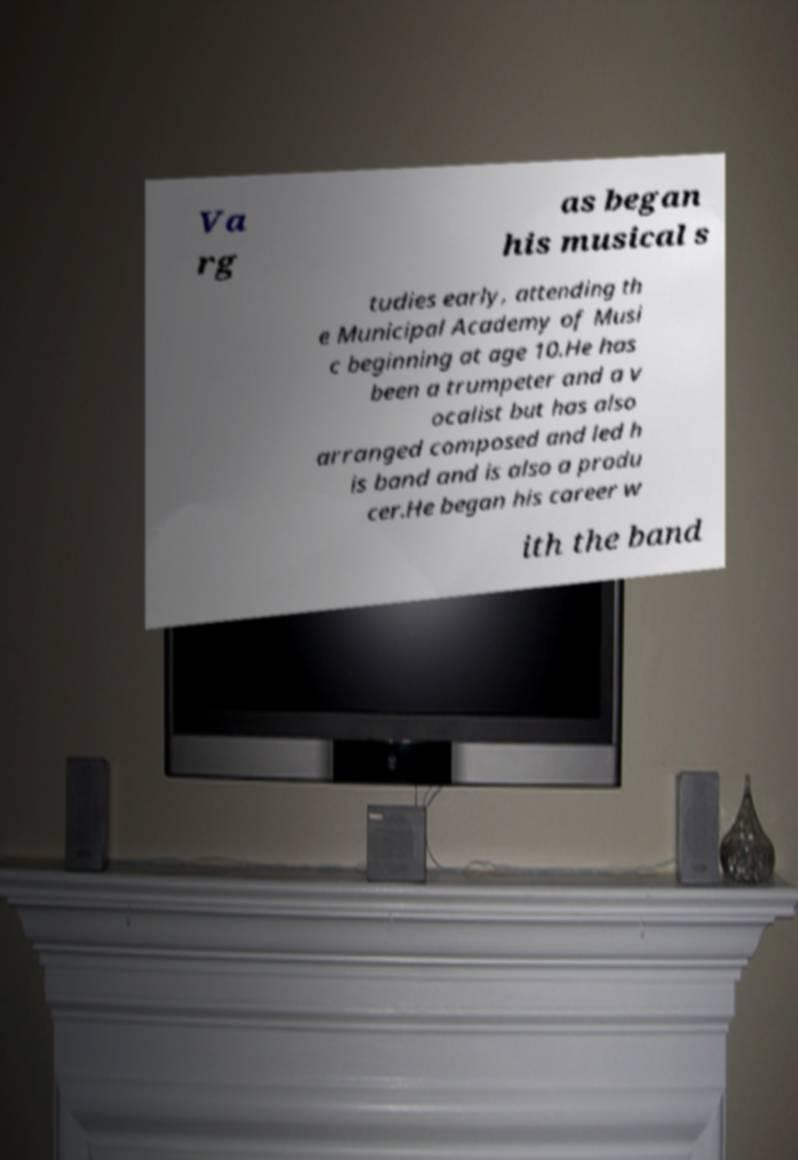What messages or text are displayed in this image? I need them in a readable, typed format. Va rg as began his musical s tudies early, attending th e Municipal Academy of Musi c beginning at age 10.He has been a trumpeter and a v ocalist but has also arranged composed and led h is band and is also a produ cer.He began his career w ith the band 